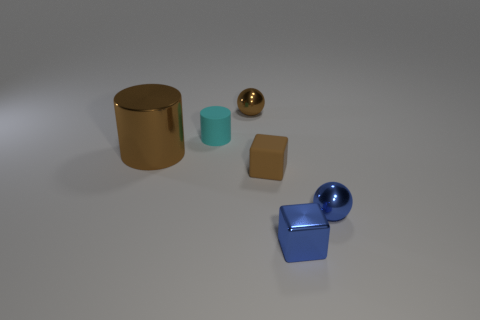Add 2 brown cubes. How many objects exist? 8 Subtract all cylinders. How many objects are left? 4 Subtract 0 red balls. How many objects are left? 6 Subtract all tiny blue metal cylinders. Subtract all blocks. How many objects are left? 4 Add 1 brown objects. How many brown objects are left? 4 Add 5 tiny rubber cylinders. How many tiny rubber cylinders exist? 6 